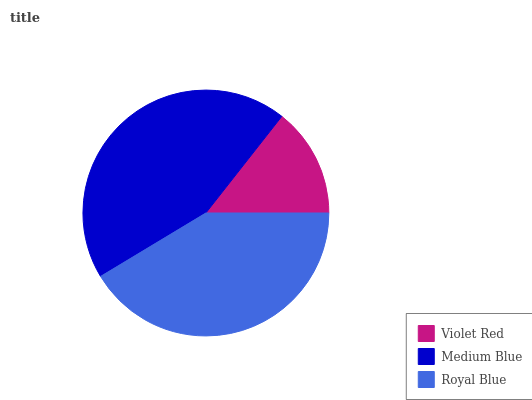Is Violet Red the minimum?
Answer yes or no. Yes. Is Medium Blue the maximum?
Answer yes or no. Yes. Is Royal Blue the minimum?
Answer yes or no. No. Is Royal Blue the maximum?
Answer yes or no. No. Is Medium Blue greater than Royal Blue?
Answer yes or no. Yes. Is Royal Blue less than Medium Blue?
Answer yes or no. Yes. Is Royal Blue greater than Medium Blue?
Answer yes or no. No. Is Medium Blue less than Royal Blue?
Answer yes or no. No. Is Royal Blue the high median?
Answer yes or no. Yes. Is Royal Blue the low median?
Answer yes or no. Yes. Is Violet Red the high median?
Answer yes or no. No. Is Violet Red the low median?
Answer yes or no. No. 